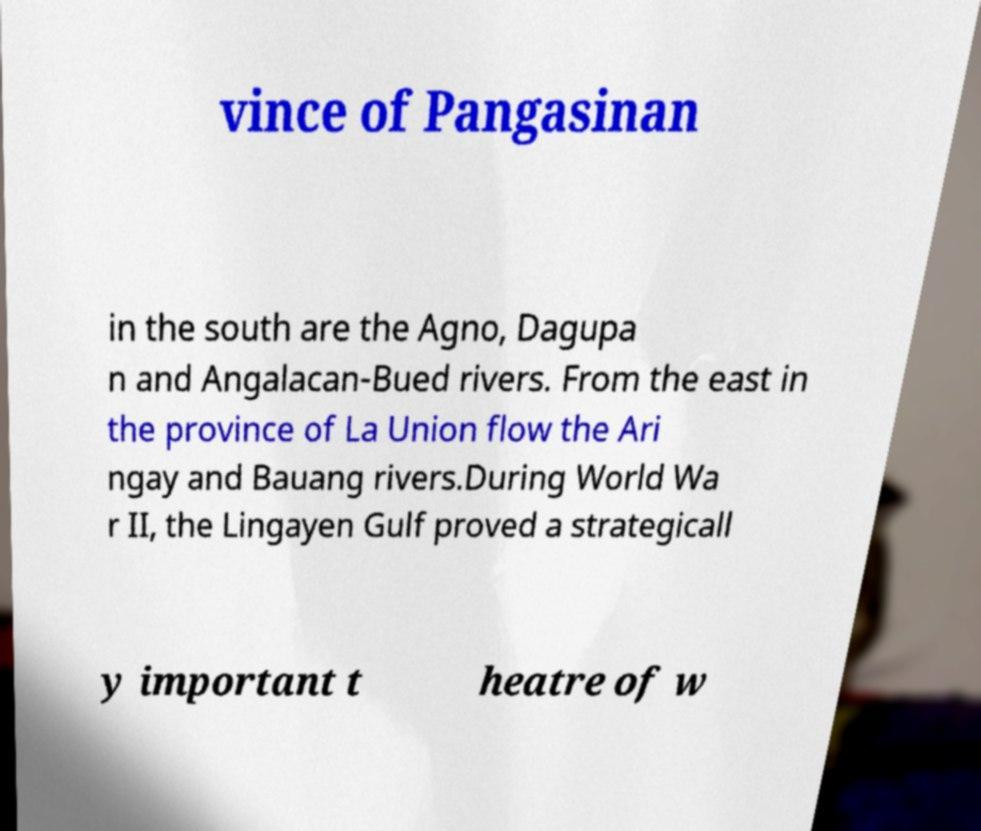For documentation purposes, I need the text within this image transcribed. Could you provide that? vince of Pangasinan in the south are the Agno, Dagupa n and Angalacan-Bued rivers. From the east in the province of La Union flow the Ari ngay and Bauang rivers.During World Wa r II, the Lingayen Gulf proved a strategicall y important t heatre of w 